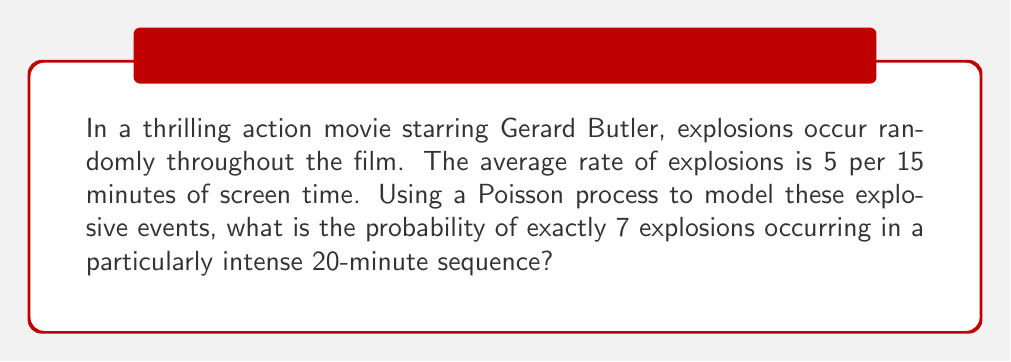Could you help me with this problem? Let's approach this step-by-step:

1) First, we need to identify the parameters of our Poisson process:
   - Let $\lambda$ be the average rate of explosions per unit time
   - Let $t$ be the time interval we're considering

2) Given information:
   - 5 explosions per 15 minutes
   - We want to find the probability for a 20-minute sequence

3) Calculate $\lambda$ for our time unit (let's use minutes):
   $\lambda = \frac{5 \text{ explosions}}{15 \text{ minutes}} = \frac{1}{3} \text{ explosions/minute}$

4) For a 20-minute sequence, our $\lambda t$ becomes:
   $\lambda t = \frac{1}{3} \times 20 = \frac{20}{3} \approx 6.67$

5) The probability of exactly $k$ events in a Poisson process is given by:
   $$P(X = k) = \frac{e^{-\lambda t}(\lambda t)^k}{k!}$$

6) We want $P(X = 7)$, so let's plug in our values:
   $$P(X = 7) = \frac{e^{-\frac{20}{3}}(\frac{20}{3})^7}{7!}$$

7) Calculate this value:
   $$P(X = 7) = \frac{e^{-6.67} \times 6.67^7}{7!} \approx 0.1542$$

8) Convert to a percentage:
   $0.1542 \times 100\% = 15.42\%$
Answer: 15.42% 